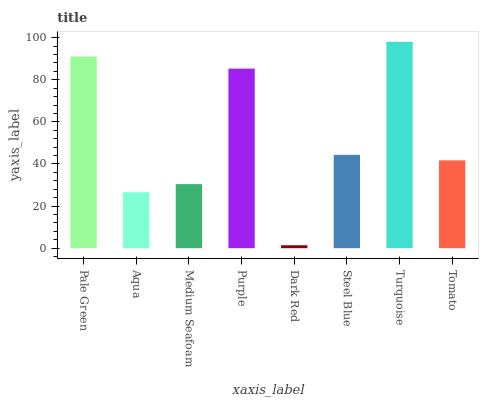Is Dark Red the minimum?
Answer yes or no. Yes. Is Turquoise the maximum?
Answer yes or no. Yes. Is Aqua the minimum?
Answer yes or no. No. Is Aqua the maximum?
Answer yes or no. No. Is Pale Green greater than Aqua?
Answer yes or no. Yes. Is Aqua less than Pale Green?
Answer yes or no. Yes. Is Aqua greater than Pale Green?
Answer yes or no. No. Is Pale Green less than Aqua?
Answer yes or no. No. Is Steel Blue the high median?
Answer yes or no. Yes. Is Tomato the low median?
Answer yes or no. Yes. Is Pale Green the high median?
Answer yes or no. No. Is Aqua the low median?
Answer yes or no. No. 